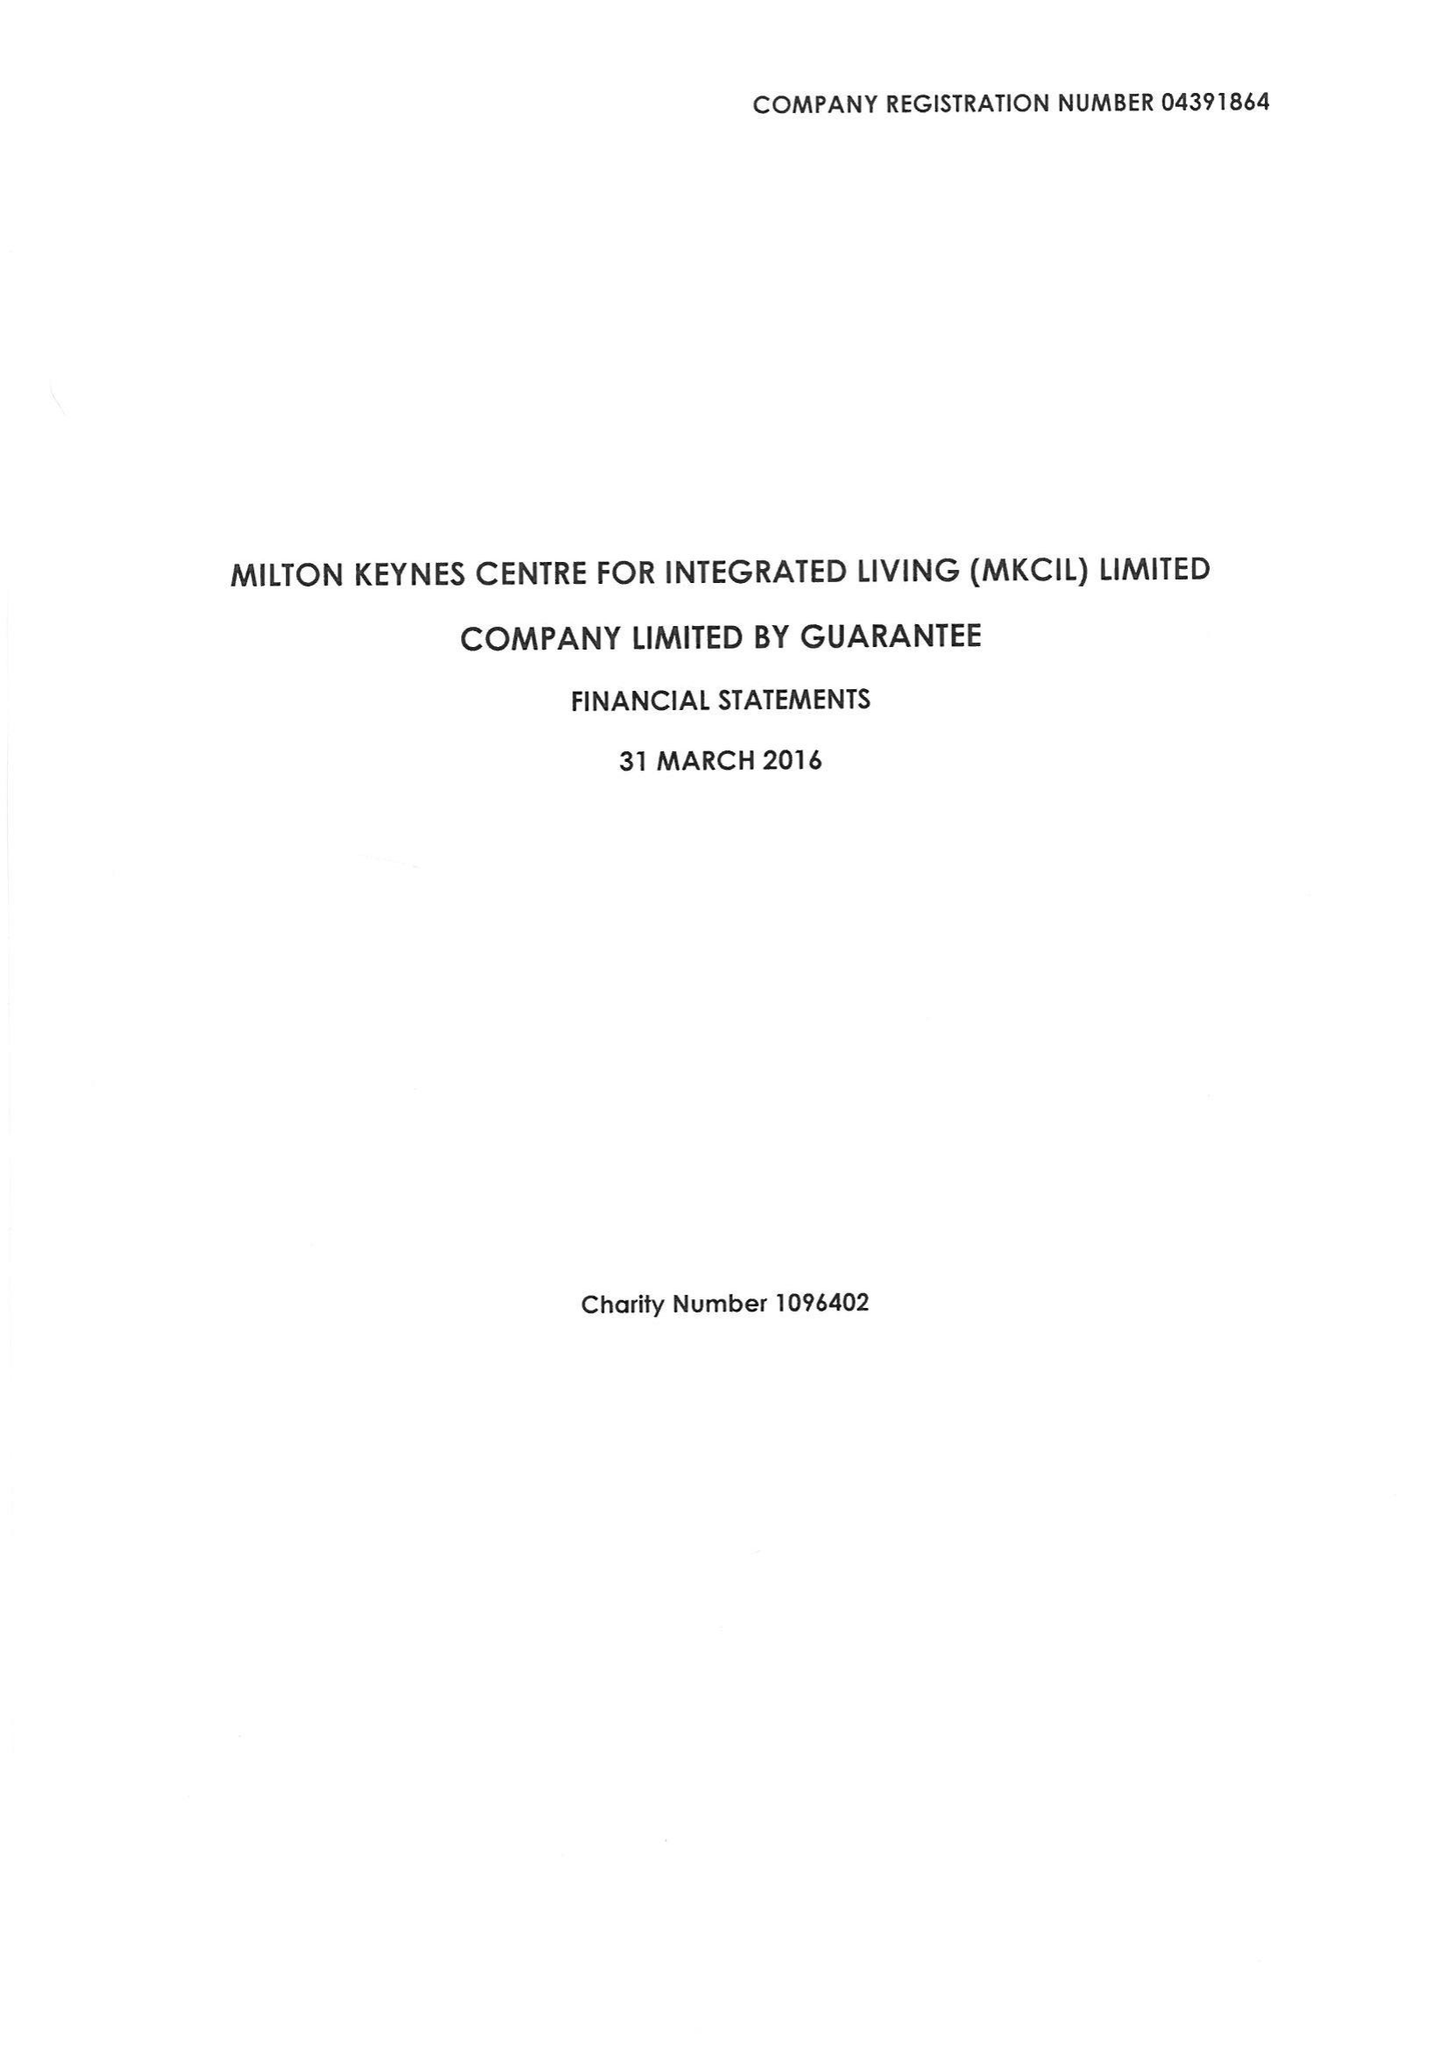What is the value for the address__post_town?
Answer the question using a single word or phrase. MILTON KEYNES 